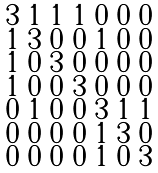Convert formula to latex. <formula><loc_0><loc_0><loc_500><loc_500>\begin{smallmatrix} 3 & 1 & 1 & 1 & 0 & 0 & 0 \\ 1 & 3 & 0 & 0 & 1 & 0 & 0 \\ 1 & 0 & 3 & 0 & 0 & 0 & 0 \\ 1 & 0 & 0 & 3 & 0 & 0 & 0 \\ 0 & 1 & 0 & 0 & 3 & 1 & 1 \\ 0 & 0 & 0 & 0 & 1 & 3 & 0 \\ 0 & 0 & 0 & 0 & 1 & 0 & 3 \end{smallmatrix}</formula> 